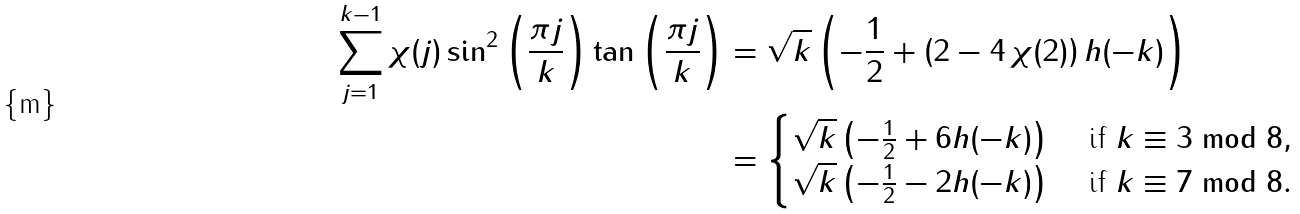Convert formula to latex. <formula><loc_0><loc_0><loc_500><loc_500>\sum _ { j = 1 } ^ { k - 1 } \chi ( j ) \sin ^ { 2 } \left ( \frac { \pi j } { k } \right ) \tan \left ( \frac { \pi j } { k } \right ) & = \sqrt { k } \left ( - \frac { 1 } { 2 } + \left ( 2 - 4 \, \chi ( 2 ) \right ) h ( - k ) \right ) \\ & = \begin{cases} \sqrt { k } \left ( - \frac { 1 } { 2 } + 6 h ( - k ) \right ) & \text { if } k \equiv 3 \bmod 8 , \\ \sqrt { k } \left ( - \frac { 1 } { 2 } - 2 h ( - k ) \right ) & \text { if } k \equiv 7 \bmod 8 . \end{cases}</formula> 